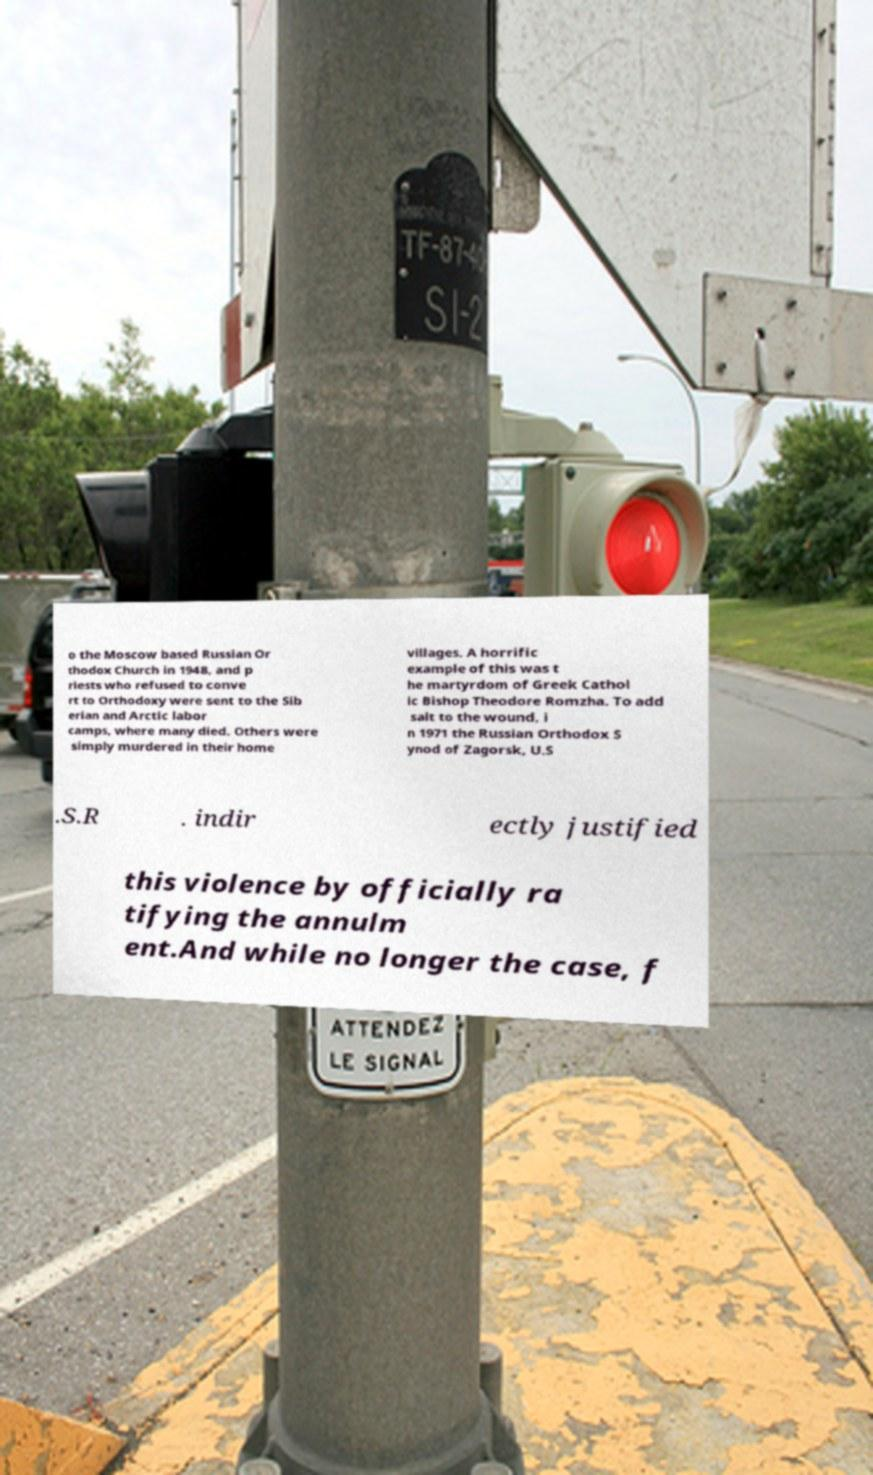Please identify and transcribe the text found in this image. o the Moscow based Russian Or thodox Church in 1948, and p riests who refused to conve rt to Orthodoxy were sent to the Sib erian and Arctic labor camps, where many died. Others were simply murdered in their home villages. A horrific example of this was t he martyrdom of Greek Cathol ic Bishop Theodore Romzha. To add salt to the wound, i n 1971 the Russian Orthodox S ynod of Zagorsk, U.S .S.R . indir ectly justified this violence by officially ra tifying the annulm ent.And while no longer the case, f 